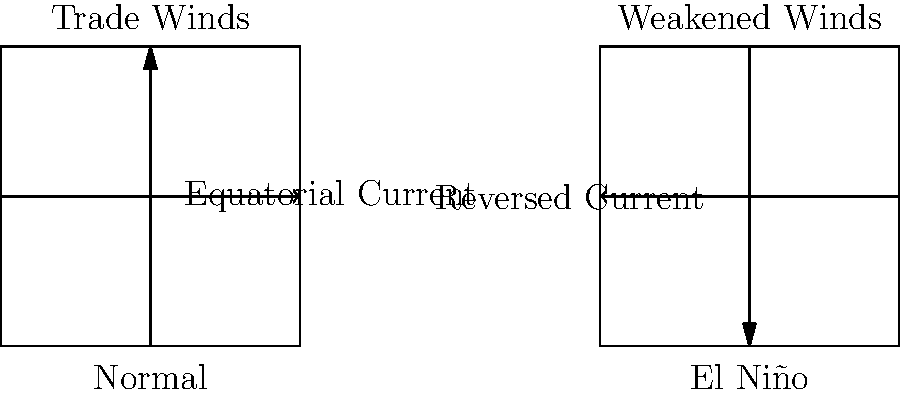Based on the diagram, how does El Niño affect the trade winds and equatorial ocean currents compared to normal conditions? To answer this question, let's analyze the diagram step-by-step:

1. Normal conditions (left side of the diagram):
   a. Trade winds are shown moving from east to west (left to right).
   b. Equatorial ocean currents flow in the same direction as the trade winds (east to west).

2. El Niño conditions (right side of the diagram):
   a. Trade winds are depicted as weakened, moving from west to east (right to left).
   b. Equatorial ocean currents are shown reversing direction, now flowing from west to east.

3. Comparing the two conditions:
   a. Wind patterns: During El Niño, the trade winds weaken and can even reverse direction.
   b. Ocean currents: The equatorial currents follow the wind pattern change, reversing direction during El Niño.

4. Impact of these changes:
   a. The weakening or reversal of trade winds reduces the upwelling of cold water along the South American coast.
   b. This leads to warmer surface waters in the eastern Pacific, which is a key characteristic of El Niño.
   c. The reversed ocean currents further reinforce the warming pattern in the eastern Pacific.

These changes in wind and ocean current patterns during El Niño have significant impacts on global weather patterns, marine ecosystems, and climate variability.
Answer: El Niño weakens/reverses trade winds and reverses equatorial ocean currents. 